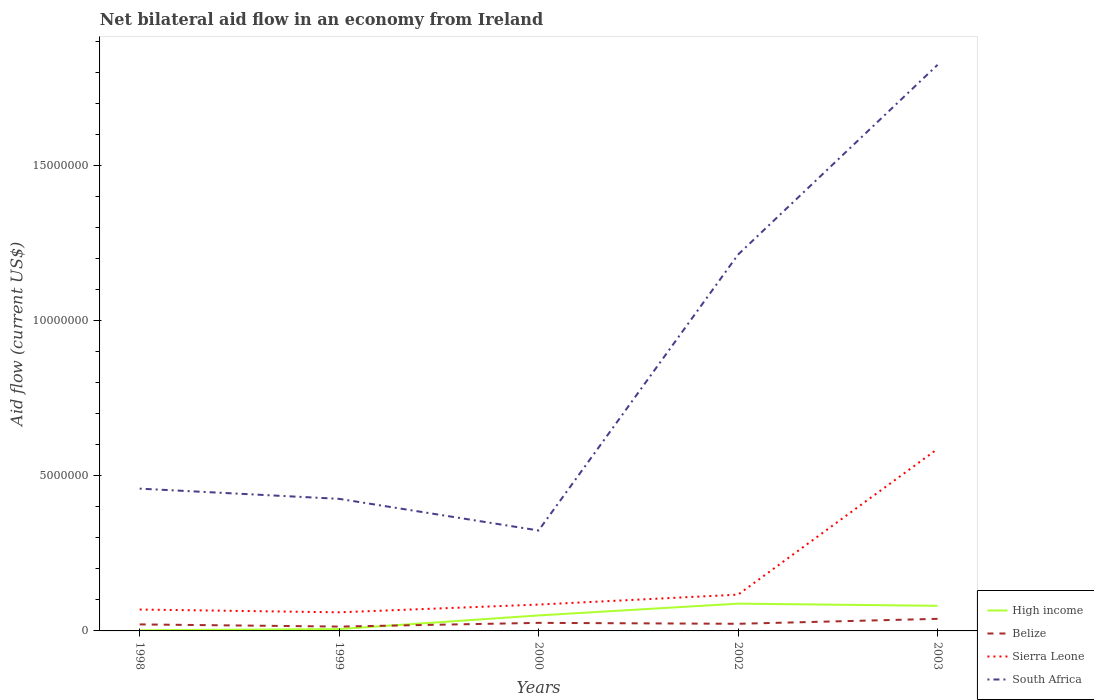How many different coloured lines are there?
Give a very brief answer. 4. Does the line corresponding to High income intersect with the line corresponding to Belize?
Offer a terse response. Yes. Is the number of lines equal to the number of legend labels?
Provide a succinct answer. Yes. Across all years, what is the maximum net bilateral aid flow in Belize?
Your answer should be compact. 1.40e+05. In which year was the net bilateral aid flow in Sierra Leone maximum?
Provide a succinct answer. 1999. What is the total net bilateral aid flow in Belize in the graph?
Provide a succinct answer. -1.20e+05. What is the difference between the highest and the second highest net bilateral aid flow in South Africa?
Your response must be concise. 1.50e+07. How many lines are there?
Ensure brevity in your answer.  4. Does the graph contain grids?
Your response must be concise. No. Where does the legend appear in the graph?
Offer a very short reply. Bottom right. How many legend labels are there?
Your response must be concise. 4. How are the legend labels stacked?
Provide a short and direct response. Vertical. What is the title of the graph?
Your response must be concise. Net bilateral aid flow in an economy from Ireland. Does "Ethiopia" appear as one of the legend labels in the graph?
Your response must be concise. No. What is the label or title of the Y-axis?
Your response must be concise. Aid flow (current US$). What is the Aid flow (current US$) in High income in 1998?
Offer a very short reply. 2.00e+04. What is the Aid flow (current US$) of Belize in 1998?
Keep it short and to the point. 2.10e+05. What is the Aid flow (current US$) in Sierra Leone in 1998?
Provide a succinct answer. 6.90e+05. What is the Aid flow (current US$) in South Africa in 1998?
Offer a very short reply. 4.59e+06. What is the Aid flow (current US$) of High income in 1999?
Your response must be concise. 6.00e+04. What is the Aid flow (current US$) of Belize in 1999?
Your answer should be very brief. 1.40e+05. What is the Aid flow (current US$) in South Africa in 1999?
Make the answer very short. 4.26e+06. What is the Aid flow (current US$) in High income in 2000?
Give a very brief answer. 5.00e+05. What is the Aid flow (current US$) in Belize in 2000?
Make the answer very short. 2.60e+05. What is the Aid flow (current US$) of Sierra Leone in 2000?
Make the answer very short. 8.50e+05. What is the Aid flow (current US$) of South Africa in 2000?
Provide a succinct answer. 3.24e+06. What is the Aid flow (current US$) in High income in 2002?
Your answer should be compact. 8.80e+05. What is the Aid flow (current US$) of Sierra Leone in 2002?
Keep it short and to the point. 1.17e+06. What is the Aid flow (current US$) in South Africa in 2002?
Give a very brief answer. 1.21e+07. What is the Aid flow (current US$) of High income in 2003?
Make the answer very short. 8.10e+05. What is the Aid flow (current US$) of Belize in 2003?
Offer a terse response. 3.90e+05. What is the Aid flow (current US$) of Sierra Leone in 2003?
Your answer should be very brief. 5.87e+06. What is the Aid flow (current US$) of South Africa in 2003?
Provide a short and direct response. 1.83e+07. Across all years, what is the maximum Aid flow (current US$) of High income?
Ensure brevity in your answer.  8.80e+05. Across all years, what is the maximum Aid flow (current US$) in Sierra Leone?
Give a very brief answer. 5.87e+06. Across all years, what is the maximum Aid flow (current US$) of South Africa?
Your answer should be compact. 1.83e+07. Across all years, what is the minimum Aid flow (current US$) in High income?
Your answer should be very brief. 2.00e+04. Across all years, what is the minimum Aid flow (current US$) of Sierra Leone?
Make the answer very short. 6.00e+05. Across all years, what is the minimum Aid flow (current US$) of South Africa?
Provide a short and direct response. 3.24e+06. What is the total Aid flow (current US$) in High income in the graph?
Your answer should be very brief. 2.27e+06. What is the total Aid flow (current US$) of Belize in the graph?
Give a very brief answer. 1.23e+06. What is the total Aid flow (current US$) of Sierra Leone in the graph?
Your answer should be compact. 9.18e+06. What is the total Aid flow (current US$) of South Africa in the graph?
Give a very brief answer. 4.25e+07. What is the difference between the Aid flow (current US$) in Belize in 1998 and that in 1999?
Offer a very short reply. 7.00e+04. What is the difference between the Aid flow (current US$) in Sierra Leone in 1998 and that in 1999?
Ensure brevity in your answer.  9.00e+04. What is the difference between the Aid flow (current US$) in High income in 1998 and that in 2000?
Your answer should be very brief. -4.80e+05. What is the difference between the Aid flow (current US$) in Sierra Leone in 1998 and that in 2000?
Offer a very short reply. -1.60e+05. What is the difference between the Aid flow (current US$) of South Africa in 1998 and that in 2000?
Make the answer very short. 1.35e+06. What is the difference between the Aid flow (current US$) in High income in 1998 and that in 2002?
Your answer should be compact. -8.60e+05. What is the difference between the Aid flow (current US$) in Sierra Leone in 1998 and that in 2002?
Give a very brief answer. -4.80e+05. What is the difference between the Aid flow (current US$) in South Africa in 1998 and that in 2002?
Your answer should be very brief. -7.55e+06. What is the difference between the Aid flow (current US$) in High income in 1998 and that in 2003?
Give a very brief answer. -7.90e+05. What is the difference between the Aid flow (current US$) in Belize in 1998 and that in 2003?
Give a very brief answer. -1.80e+05. What is the difference between the Aid flow (current US$) of Sierra Leone in 1998 and that in 2003?
Offer a terse response. -5.18e+06. What is the difference between the Aid flow (current US$) in South Africa in 1998 and that in 2003?
Keep it short and to the point. -1.37e+07. What is the difference between the Aid flow (current US$) of High income in 1999 and that in 2000?
Keep it short and to the point. -4.40e+05. What is the difference between the Aid flow (current US$) of South Africa in 1999 and that in 2000?
Offer a very short reply. 1.02e+06. What is the difference between the Aid flow (current US$) in High income in 1999 and that in 2002?
Give a very brief answer. -8.20e+05. What is the difference between the Aid flow (current US$) of Sierra Leone in 1999 and that in 2002?
Provide a short and direct response. -5.70e+05. What is the difference between the Aid flow (current US$) in South Africa in 1999 and that in 2002?
Make the answer very short. -7.88e+06. What is the difference between the Aid flow (current US$) in High income in 1999 and that in 2003?
Give a very brief answer. -7.50e+05. What is the difference between the Aid flow (current US$) of Belize in 1999 and that in 2003?
Give a very brief answer. -2.50e+05. What is the difference between the Aid flow (current US$) in Sierra Leone in 1999 and that in 2003?
Ensure brevity in your answer.  -5.27e+06. What is the difference between the Aid flow (current US$) in South Africa in 1999 and that in 2003?
Provide a short and direct response. -1.40e+07. What is the difference between the Aid flow (current US$) in High income in 2000 and that in 2002?
Offer a very short reply. -3.80e+05. What is the difference between the Aid flow (current US$) of Sierra Leone in 2000 and that in 2002?
Your answer should be compact. -3.20e+05. What is the difference between the Aid flow (current US$) of South Africa in 2000 and that in 2002?
Your answer should be very brief. -8.90e+06. What is the difference between the Aid flow (current US$) in High income in 2000 and that in 2003?
Make the answer very short. -3.10e+05. What is the difference between the Aid flow (current US$) of Belize in 2000 and that in 2003?
Offer a terse response. -1.30e+05. What is the difference between the Aid flow (current US$) in Sierra Leone in 2000 and that in 2003?
Your answer should be very brief. -5.02e+06. What is the difference between the Aid flow (current US$) of South Africa in 2000 and that in 2003?
Keep it short and to the point. -1.50e+07. What is the difference between the Aid flow (current US$) in Sierra Leone in 2002 and that in 2003?
Make the answer very short. -4.70e+06. What is the difference between the Aid flow (current US$) in South Africa in 2002 and that in 2003?
Your answer should be very brief. -6.12e+06. What is the difference between the Aid flow (current US$) in High income in 1998 and the Aid flow (current US$) in Belize in 1999?
Your response must be concise. -1.20e+05. What is the difference between the Aid flow (current US$) of High income in 1998 and the Aid flow (current US$) of Sierra Leone in 1999?
Ensure brevity in your answer.  -5.80e+05. What is the difference between the Aid flow (current US$) of High income in 1998 and the Aid flow (current US$) of South Africa in 1999?
Provide a short and direct response. -4.24e+06. What is the difference between the Aid flow (current US$) in Belize in 1998 and the Aid flow (current US$) in Sierra Leone in 1999?
Keep it short and to the point. -3.90e+05. What is the difference between the Aid flow (current US$) in Belize in 1998 and the Aid flow (current US$) in South Africa in 1999?
Give a very brief answer. -4.05e+06. What is the difference between the Aid flow (current US$) in Sierra Leone in 1998 and the Aid flow (current US$) in South Africa in 1999?
Keep it short and to the point. -3.57e+06. What is the difference between the Aid flow (current US$) of High income in 1998 and the Aid flow (current US$) of Sierra Leone in 2000?
Offer a terse response. -8.30e+05. What is the difference between the Aid flow (current US$) of High income in 1998 and the Aid flow (current US$) of South Africa in 2000?
Your answer should be compact. -3.22e+06. What is the difference between the Aid flow (current US$) in Belize in 1998 and the Aid flow (current US$) in Sierra Leone in 2000?
Ensure brevity in your answer.  -6.40e+05. What is the difference between the Aid flow (current US$) of Belize in 1998 and the Aid flow (current US$) of South Africa in 2000?
Offer a terse response. -3.03e+06. What is the difference between the Aid flow (current US$) in Sierra Leone in 1998 and the Aid flow (current US$) in South Africa in 2000?
Keep it short and to the point. -2.55e+06. What is the difference between the Aid flow (current US$) in High income in 1998 and the Aid flow (current US$) in Belize in 2002?
Make the answer very short. -2.10e+05. What is the difference between the Aid flow (current US$) of High income in 1998 and the Aid flow (current US$) of Sierra Leone in 2002?
Give a very brief answer. -1.15e+06. What is the difference between the Aid flow (current US$) in High income in 1998 and the Aid flow (current US$) in South Africa in 2002?
Your response must be concise. -1.21e+07. What is the difference between the Aid flow (current US$) of Belize in 1998 and the Aid flow (current US$) of Sierra Leone in 2002?
Ensure brevity in your answer.  -9.60e+05. What is the difference between the Aid flow (current US$) in Belize in 1998 and the Aid flow (current US$) in South Africa in 2002?
Provide a short and direct response. -1.19e+07. What is the difference between the Aid flow (current US$) of Sierra Leone in 1998 and the Aid flow (current US$) of South Africa in 2002?
Your answer should be compact. -1.14e+07. What is the difference between the Aid flow (current US$) in High income in 1998 and the Aid flow (current US$) in Belize in 2003?
Provide a succinct answer. -3.70e+05. What is the difference between the Aid flow (current US$) in High income in 1998 and the Aid flow (current US$) in Sierra Leone in 2003?
Provide a succinct answer. -5.85e+06. What is the difference between the Aid flow (current US$) of High income in 1998 and the Aid flow (current US$) of South Africa in 2003?
Offer a very short reply. -1.82e+07. What is the difference between the Aid flow (current US$) of Belize in 1998 and the Aid flow (current US$) of Sierra Leone in 2003?
Give a very brief answer. -5.66e+06. What is the difference between the Aid flow (current US$) of Belize in 1998 and the Aid flow (current US$) of South Africa in 2003?
Give a very brief answer. -1.80e+07. What is the difference between the Aid flow (current US$) of Sierra Leone in 1998 and the Aid flow (current US$) of South Africa in 2003?
Offer a terse response. -1.76e+07. What is the difference between the Aid flow (current US$) of High income in 1999 and the Aid flow (current US$) of Belize in 2000?
Give a very brief answer. -2.00e+05. What is the difference between the Aid flow (current US$) of High income in 1999 and the Aid flow (current US$) of Sierra Leone in 2000?
Your answer should be very brief. -7.90e+05. What is the difference between the Aid flow (current US$) of High income in 1999 and the Aid flow (current US$) of South Africa in 2000?
Your answer should be very brief. -3.18e+06. What is the difference between the Aid flow (current US$) in Belize in 1999 and the Aid flow (current US$) in Sierra Leone in 2000?
Offer a very short reply. -7.10e+05. What is the difference between the Aid flow (current US$) of Belize in 1999 and the Aid flow (current US$) of South Africa in 2000?
Make the answer very short. -3.10e+06. What is the difference between the Aid flow (current US$) of Sierra Leone in 1999 and the Aid flow (current US$) of South Africa in 2000?
Provide a succinct answer. -2.64e+06. What is the difference between the Aid flow (current US$) of High income in 1999 and the Aid flow (current US$) of Sierra Leone in 2002?
Give a very brief answer. -1.11e+06. What is the difference between the Aid flow (current US$) of High income in 1999 and the Aid flow (current US$) of South Africa in 2002?
Offer a terse response. -1.21e+07. What is the difference between the Aid flow (current US$) in Belize in 1999 and the Aid flow (current US$) in Sierra Leone in 2002?
Provide a succinct answer. -1.03e+06. What is the difference between the Aid flow (current US$) of Belize in 1999 and the Aid flow (current US$) of South Africa in 2002?
Your response must be concise. -1.20e+07. What is the difference between the Aid flow (current US$) of Sierra Leone in 1999 and the Aid flow (current US$) of South Africa in 2002?
Make the answer very short. -1.15e+07. What is the difference between the Aid flow (current US$) of High income in 1999 and the Aid flow (current US$) of Belize in 2003?
Provide a short and direct response. -3.30e+05. What is the difference between the Aid flow (current US$) of High income in 1999 and the Aid flow (current US$) of Sierra Leone in 2003?
Your answer should be compact. -5.81e+06. What is the difference between the Aid flow (current US$) in High income in 1999 and the Aid flow (current US$) in South Africa in 2003?
Provide a short and direct response. -1.82e+07. What is the difference between the Aid flow (current US$) of Belize in 1999 and the Aid flow (current US$) of Sierra Leone in 2003?
Your answer should be very brief. -5.73e+06. What is the difference between the Aid flow (current US$) in Belize in 1999 and the Aid flow (current US$) in South Africa in 2003?
Give a very brief answer. -1.81e+07. What is the difference between the Aid flow (current US$) in Sierra Leone in 1999 and the Aid flow (current US$) in South Africa in 2003?
Give a very brief answer. -1.77e+07. What is the difference between the Aid flow (current US$) of High income in 2000 and the Aid flow (current US$) of Belize in 2002?
Provide a succinct answer. 2.70e+05. What is the difference between the Aid flow (current US$) in High income in 2000 and the Aid flow (current US$) in Sierra Leone in 2002?
Your answer should be very brief. -6.70e+05. What is the difference between the Aid flow (current US$) of High income in 2000 and the Aid flow (current US$) of South Africa in 2002?
Keep it short and to the point. -1.16e+07. What is the difference between the Aid flow (current US$) in Belize in 2000 and the Aid flow (current US$) in Sierra Leone in 2002?
Give a very brief answer. -9.10e+05. What is the difference between the Aid flow (current US$) of Belize in 2000 and the Aid flow (current US$) of South Africa in 2002?
Ensure brevity in your answer.  -1.19e+07. What is the difference between the Aid flow (current US$) of Sierra Leone in 2000 and the Aid flow (current US$) of South Africa in 2002?
Offer a terse response. -1.13e+07. What is the difference between the Aid flow (current US$) of High income in 2000 and the Aid flow (current US$) of Sierra Leone in 2003?
Your response must be concise. -5.37e+06. What is the difference between the Aid flow (current US$) of High income in 2000 and the Aid flow (current US$) of South Africa in 2003?
Keep it short and to the point. -1.78e+07. What is the difference between the Aid flow (current US$) of Belize in 2000 and the Aid flow (current US$) of Sierra Leone in 2003?
Offer a very short reply. -5.61e+06. What is the difference between the Aid flow (current US$) of Belize in 2000 and the Aid flow (current US$) of South Africa in 2003?
Your answer should be compact. -1.80e+07. What is the difference between the Aid flow (current US$) of Sierra Leone in 2000 and the Aid flow (current US$) of South Africa in 2003?
Provide a short and direct response. -1.74e+07. What is the difference between the Aid flow (current US$) of High income in 2002 and the Aid flow (current US$) of Sierra Leone in 2003?
Offer a very short reply. -4.99e+06. What is the difference between the Aid flow (current US$) in High income in 2002 and the Aid flow (current US$) in South Africa in 2003?
Keep it short and to the point. -1.74e+07. What is the difference between the Aid flow (current US$) in Belize in 2002 and the Aid flow (current US$) in Sierra Leone in 2003?
Your answer should be very brief. -5.64e+06. What is the difference between the Aid flow (current US$) in Belize in 2002 and the Aid flow (current US$) in South Africa in 2003?
Offer a terse response. -1.80e+07. What is the difference between the Aid flow (current US$) of Sierra Leone in 2002 and the Aid flow (current US$) of South Africa in 2003?
Give a very brief answer. -1.71e+07. What is the average Aid flow (current US$) of High income per year?
Ensure brevity in your answer.  4.54e+05. What is the average Aid flow (current US$) in Belize per year?
Your answer should be very brief. 2.46e+05. What is the average Aid flow (current US$) of Sierra Leone per year?
Offer a very short reply. 1.84e+06. What is the average Aid flow (current US$) in South Africa per year?
Provide a succinct answer. 8.50e+06. In the year 1998, what is the difference between the Aid flow (current US$) of High income and Aid flow (current US$) of Sierra Leone?
Ensure brevity in your answer.  -6.70e+05. In the year 1998, what is the difference between the Aid flow (current US$) in High income and Aid flow (current US$) in South Africa?
Your answer should be compact. -4.57e+06. In the year 1998, what is the difference between the Aid flow (current US$) in Belize and Aid flow (current US$) in Sierra Leone?
Offer a very short reply. -4.80e+05. In the year 1998, what is the difference between the Aid flow (current US$) of Belize and Aid flow (current US$) of South Africa?
Ensure brevity in your answer.  -4.38e+06. In the year 1998, what is the difference between the Aid flow (current US$) of Sierra Leone and Aid flow (current US$) of South Africa?
Ensure brevity in your answer.  -3.90e+06. In the year 1999, what is the difference between the Aid flow (current US$) in High income and Aid flow (current US$) in Sierra Leone?
Ensure brevity in your answer.  -5.40e+05. In the year 1999, what is the difference between the Aid flow (current US$) of High income and Aid flow (current US$) of South Africa?
Provide a short and direct response. -4.20e+06. In the year 1999, what is the difference between the Aid flow (current US$) of Belize and Aid flow (current US$) of Sierra Leone?
Provide a succinct answer. -4.60e+05. In the year 1999, what is the difference between the Aid flow (current US$) in Belize and Aid flow (current US$) in South Africa?
Your response must be concise. -4.12e+06. In the year 1999, what is the difference between the Aid flow (current US$) in Sierra Leone and Aid flow (current US$) in South Africa?
Offer a very short reply. -3.66e+06. In the year 2000, what is the difference between the Aid flow (current US$) of High income and Aid flow (current US$) of Belize?
Offer a terse response. 2.40e+05. In the year 2000, what is the difference between the Aid flow (current US$) in High income and Aid flow (current US$) in Sierra Leone?
Offer a very short reply. -3.50e+05. In the year 2000, what is the difference between the Aid flow (current US$) in High income and Aid flow (current US$) in South Africa?
Your response must be concise. -2.74e+06. In the year 2000, what is the difference between the Aid flow (current US$) of Belize and Aid flow (current US$) of Sierra Leone?
Ensure brevity in your answer.  -5.90e+05. In the year 2000, what is the difference between the Aid flow (current US$) in Belize and Aid flow (current US$) in South Africa?
Your answer should be very brief. -2.98e+06. In the year 2000, what is the difference between the Aid flow (current US$) of Sierra Leone and Aid flow (current US$) of South Africa?
Offer a very short reply. -2.39e+06. In the year 2002, what is the difference between the Aid flow (current US$) of High income and Aid flow (current US$) of Belize?
Make the answer very short. 6.50e+05. In the year 2002, what is the difference between the Aid flow (current US$) of High income and Aid flow (current US$) of South Africa?
Provide a short and direct response. -1.13e+07. In the year 2002, what is the difference between the Aid flow (current US$) in Belize and Aid flow (current US$) in Sierra Leone?
Your response must be concise. -9.40e+05. In the year 2002, what is the difference between the Aid flow (current US$) in Belize and Aid flow (current US$) in South Africa?
Keep it short and to the point. -1.19e+07. In the year 2002, what is the difference between the Aid flow (current US$) in Sierra Leone and Aid flow (current US$) in South Africa?
Your answer should be compact. -1.10e+07. In the year 2003, what is the difference between the Aid flow (current US$) in High income and Aid flow (current US$) in Sierra Leone?
Your answer should be very brief. -5.06e+06. In the year 2003, what is the difference between the Aid flow (current US$) of High income and Aid flow (current US$) of South Africa?
Your answer should be compact. -1.74e+07. In the year 2003, what is the difference between the Aid flow (current US$) in Belize and Aid flow (current US$) in Sierra Leone?
Give a very brief answer. -5.48e+06. In the year 2003, what is the difference between the Aid flow (current US$) in Belize and Aid flow (current US$) in South Africa?
Provide a succinct answer. -1.79e+07. In the year 2003, what is the difference between the Aid flow (current US$) of Sierra Leone and Aid flow (current US$) of South Africa?
Ensure brevity in your answer.  -1.24e+07. What is the ratio of the Aid flow (current US$) in High income in 1998 to that in 1999?
Your response must be concise. 0.33. What is the ratio of the Aid flow (current US$) in Belize in 1998 to that in 1999?
Provide a succinct answer. 1.5. What is the ratio of the Aid flow (current US$) in Sierra Leone in 1998 to that in 1999?
Offer a very short reply. 1.15. What is the ratio of the Aid flow (current US$) of South Africa in 1998 to that in 1999?
Your response must be concise. 1.08. What is the ratio of the Aid flow (current US$) in High income in 1998 to that in 2000?
Your answer should be very brief. 0.04. What is the ratio of the Aid flow (current US$) in Belize in 1998 to that in 2000?
Keep it short and to the point. 0.81. What is the ratio of the Aid flow (current US$) of Sierra Leone in 1998 to that in 2000?
Ensure brevity in your answer.  0.81. What is the ratio of the Aid flow (current US$) of South Africa in 1998 to that in 2000?
Provide a succinct answer. 1.42. What is the ratio of the Aid flow (current US$) in High income in 1998 to that in 2002?
Make the answer very short. 0.02. What is the ratio of the Aid flow (current US$) in Belize in 1998 to that in 2002?
Provide a short and direct response. 0.91. What is the ratio of the Aid flow (current US$) in Sierra Leone in 1998 to that in 2002?
Your answer should be very brief. 0.59. What is the ratio of the Aid flow (current US$) of South Africa in 1998 to that in 2002?
Your answer should be compact. 0.38. What is the ratio of the Aid flow (current US$) in High income in 1998 to that in 2003?
Your answer should be compact. 0.02. What is the ratio of the Aid flow (current US$) of Belize in 1998 to that in 2003?
Your answer should be compact. 0.54. What is the ratio of the Aid flow (current US$) in Sierra Leone in 1998 to that in 2003?
Provide a succinct answer. 0.12. What is the ratio of the Aid flow (current US$) of South Africa in 1998 to that in 2003?
Your answer should be very brief. 0.25. What is the ratio of the Aid flow (current US$) in High income in 1999 to that in 2000?
Offer a very short reply. 0.12. What is the ratio of the Aid flow (current US$) of Belize in 1999 to that in 2000?
Your response must be concise. 0.54. What is the ratio of the Aid flow (current US$) of Sierra Leone in 1999 to that in 2000?
Provide a short and direct response. 0.71. What is the ratio of the Aid flow (current US$) in South Africa in 1999 to that in 2000?
Your answer should be very brief. 1.31. What is the ratio of the Aid flow (current US$) of High income in 1999 to that in 2002?
Your response must be concise. 0.07. What is the ratio of the Aid flow (current US$) of Belize in 1999 to that in 2002?
Provide a succinct answer. 0.61. What is the ratio of the Aid flow (current US$) of Sierra Leone in 1999 to that in 2002?
Your answer should be compact. 0.51. What is the ratio of the Aid flow (current US$) in South Africa in 1999 to that in 2002?
Offer a terse response. 0.35. What is the ratio of the Aid flow (current US$) of High income in 1999 to that in 2003?
Keep it short and to the point. 0.07. What is the ratio of the Aid flow (current US$) of Belize in 1999 to that in 2003?
Your answer should be very brief. 0.36. What is the ratio of the Aid flow (current US$) in Sierra Leone in 1999 to that in 2003?
Ensure brevity in your answer.  0.1. What is the ratio of the Aid flow (current US$) in South Africa in 1999 to that in 2003?
Give a very brief answer. 0.23. What is the ratio of the Aid flow (current US$) of High income in 2000 to that in 2002?
Provide a short and direct response. 0.57. What is the ratio of the Aid flow (current US$) of Belize in 2000 to that in 2002?
Make the answer very short. 1.13. What is the ratio of the Aid flow (current US$) in Sierra Leone in 2000 to that in 2002?
Ensure brevity in your answer.  0.73. What is the ratio of the Aid flow (current US$) of South Africa in 2000 to that in 2002?
Keep it short and to the point. 0.27. What is the ratio of the Aid flow (current US$) in High income in 2000 to that in 2003?
Keep it short and to the point. 0.62. What is the ratio of the Aid flow (current US$) of Sierra Leone in 2000 to that in 2003?
Give a very brief answer. 0.14. What is the ratio of the Aid flow (current US$) of South Africa in 2000 to that in 2003?
Ensure brevity in your answer.  0.18. What is the ratio of the Aid flow (current US$) in High income in 2002 to that in 2003?
Offer a terse response. 1.09. What is the ratio of the Aid flow (current US$) in Belize in 2002 to that in 2003?
Keep it short and to the point. 0.59. What is the ratio of the Aid flow (current US$) in Sierra Leone in 2002 to that in 2003?
Provide a short and direct response. 0.2. What is the ratio of the Aid flow (current US$) of South Africa in 2002 to that in 2003?
Make the answer very short. 0.66. What is the difference between the highest and the second highest Aid flow (current US$) in Sierra Leone?
Offer a very short reply. 4.70e+06. What is the difference between the highest and the second highest Aid flow (current US$) in South Africa?
Provide a succinct answer. 6.12e+06. What is the difference between the highest and the lowest Aid flow (current US$) of High income?
Give a very brief answer. 8.60e+05. What is the difference between the highest and the lowest Aid flow (current US$) of Belize?
Your answer should be compact. 2.50e+05. What is the difference between the highest and the lowest Aid flow (current US$) in Sierra Leone?
Provide a succinct answer. 5.27e+06. What is the difference between the highest and the lowest Aid flow (current US$) in South Africa?
Your answer should be compact. 1.50e+07. 